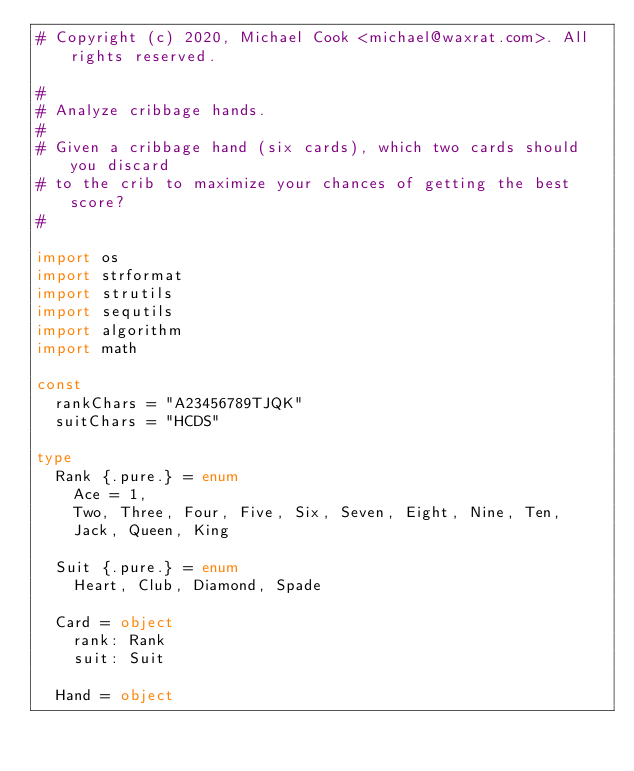Convert code to text. <code><loc_0><loc_0><loc_500><loc_500><_Nim_># Copyright (c) 2020, Michael Cook <michael@waxrat.com>. All rights reserved.

#
# Analyze cribbage hands.
#
# Given a cribbage hand (six cards), which two cards should you discard
# to the crib to maximize your chances of getting the best score?
#

import os
import strformat
import strutils
import sequtils
import algorithm
import math

const
  rankChars = "A23456789TJQK"
  suitChars = "HCDS"

type
  Rank {.pure.} = enum
    Ace = 1,
    Two, Three, Four, Five, Six, Seven, Eight, Nine, Ten,
    Jack, Queen, King

  Suit {.pure.} = enum
    Heart, Club, Diamond, Spade

  Card = object
    rank: Rank
    suit: Suit

  Hand = object</code> 